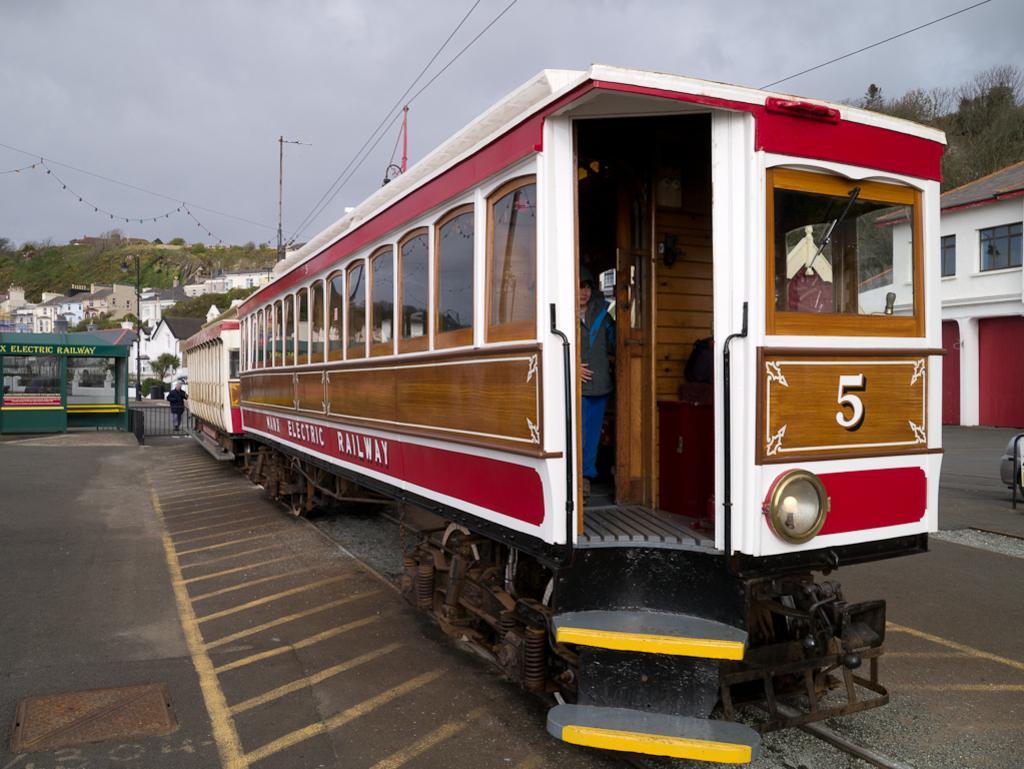In one or two sentences, can you explain what this image depicts? In this image I can see the ground, a train which is brown, red and white in color on the ground and few persons in the train. In the background I can see few trees, few buildings, few wires, few poles and the sky. 